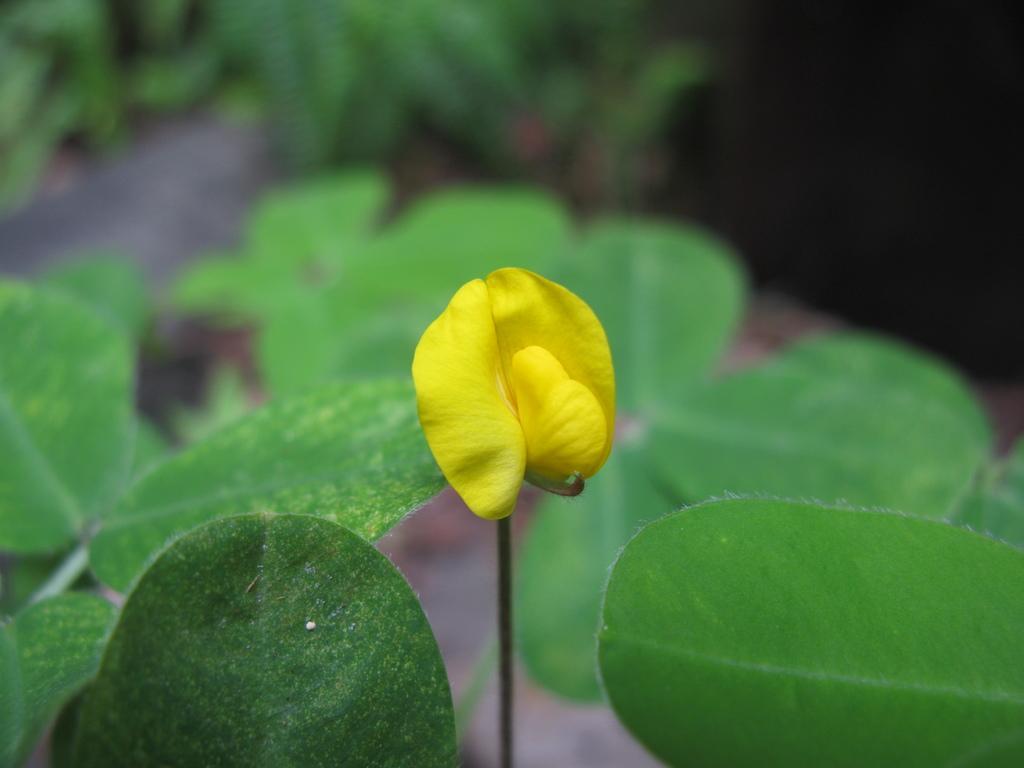Could you give a brief overview of what you see in this image? In this image there is a yellow flower. Few leaves are there. In the background there are plants. 